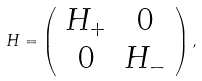Convert formula to latex. <formula><loc_0><loc_0><loc_500><loc_500>H = \left ( \begin{array} { c c } H _ { + } & 0 \\ 0 & H _ { - } \\ \end{array} \right ) ,</formula> 